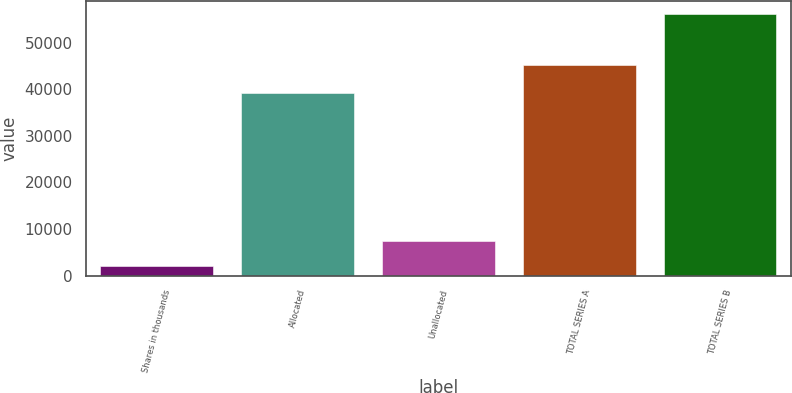Convert chart. <chart><loc_0><loc_0><loc_500><loc_500><bar_chart><fcel>Shares in thousands<fcel>Allocated<fcel>Unallocated<fcel>TOTAL SERIES A<fcel>TOTAL SERIES B<nl><fcel>2016<fcel>39241<fcel>7438.8<fcel>45336<fcel>56244<nl></chart> 